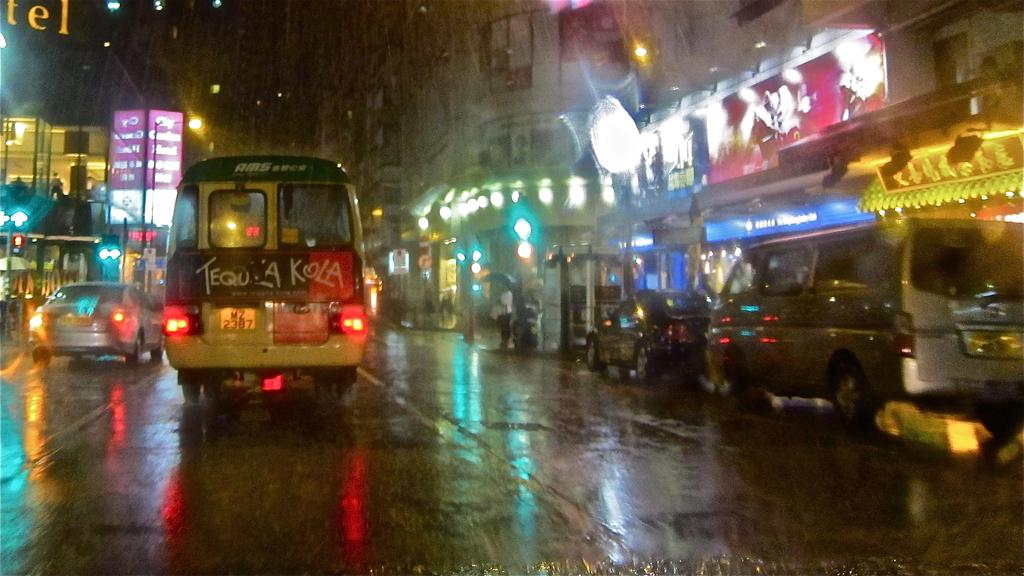<image>
Share a concise interpretation of the image provided. a brightly lit street with a van that has the letter K on it 